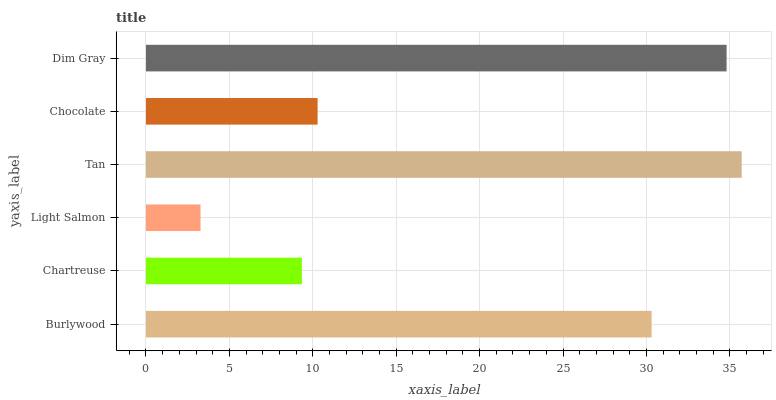Is Light Salmon the minimum?
Answer yes or no. Yes. Is Tan the maximum?
Answer yes or no. Yes. Is Chartreuse the minimum?
Answer yes or no. No. Is Chartreuse the maximum?
Answer yes or no. No. Is Burlywood greater than Chartreuse?
Answer yes or no. Yes. Is Chartreuse less than Burlywood?
Answer yes or no. Yes. Is Chartreuse greater than Burlywood?
Answer yes or no. No. Is Burlywood less than Chartreuse?
Answer yes or no. No. Is Burlywood the high median?
Answer yes or no. Yes. Is Chocolate the low median?
Answer yes or no. Yes. Is Chartreuse the high median?
Answer yes or no. No. Is Tan the low median?
Answer yes or no. No. 